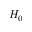Convert formula to latex. <formula><loc_0><loc_0><loc_500><loc_500>H _ { 0 }</formula> 